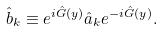Convert formula to latex. <formula><loc_0><loc_0><loc_500><loc_500>\hat { b } _ { k } \equiv e ^ { i \hat { G } ( { y } ) } \hat { a } _ { k } e ^ { - i \hat { G } ( { y } ) } .</formula> 